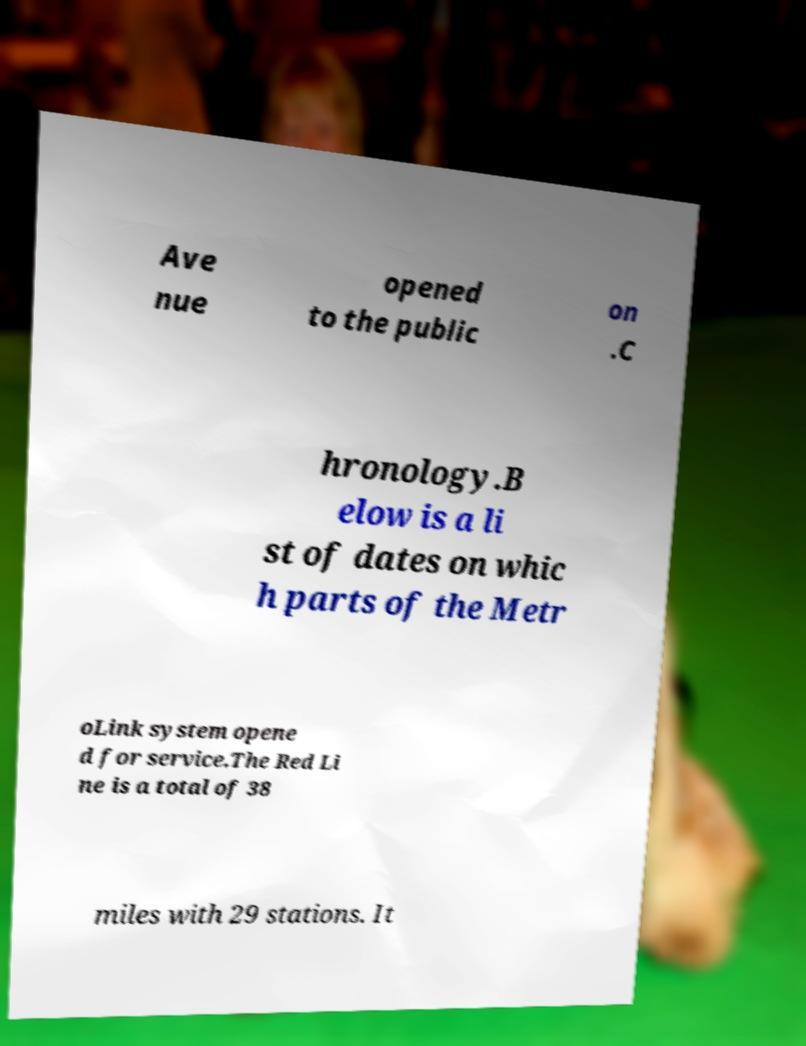Can you read and provide the text displayed in the image?This photo seems to have some interesting text. Can you extract and type it out for me? Ave nue opened to the public on .C hronology.B elow is a li st of dates on whic h parts of the Metr oLink system opene d for service.The Red Li ne is a total of 38 miles with 29 stations. It 